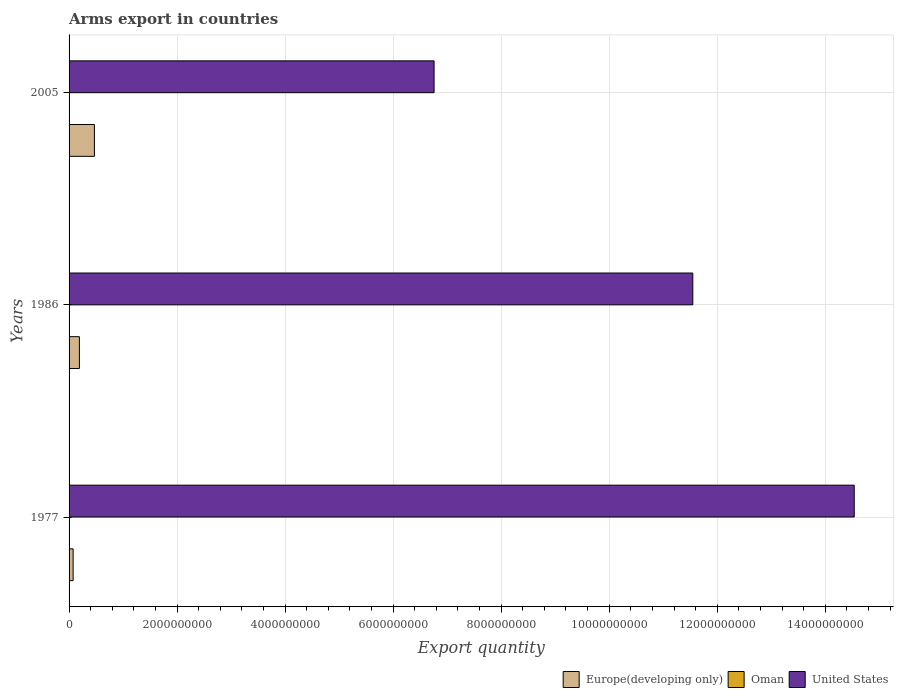How many groups of bars are there?
Keep it short and to the point. 3. Are the number of bars on each tick of the Y-axis equal?
Provide a short and direct response. Yes. How many bars are there on the 2nd tick from the top?
Make the answer very short. 3. How many bars are there on the 1st tick from the bottom?
Your response must be concise. 3. What is the label of the 3rd group of bars from the top?
Provide a short and direct response. 1977. What is the total arms export in Oman in 2005?
Provide a succinct answer. 1.00e+06. Across all years, what is the maximum total arms export in Europe(developing only)?
Give a very brief answer. 4.69e+08. Across all years, what is the minimum total arms export in Oman?
Offer a very short reply. 1.00e+06. In which year was the total arms export in United States maximum?
Your answer should be very brief. 1977. In which year was the total arms export in Europe(developing only) minimum?
Your answer should be compact. 1977. What is the total total arms export in United States in the graph?
Give a very brief answer. 3.28e+1. What is the difference between the total arms export in Oman in 1977 and the total arms export in Europe(developing only) in 1986?
Give a very brief answer. -1.86e+08. What is the average total arms export in Oman per year?
Make the answer very short. 3.67e+06. In the year 1986, what is the difference between the total arms export in Oman and total arms export in Europe(developing only)?
Offer a terse response. -1.86e+08. What is the ratio of the total arms export in Europe(developing only) in 1977 to that in 2005?
Your answer should be very brief. 0.16. What is the difference between the highest and the second highest total arms export in United States?
Provide a succinct answer. 2.99e+09. What is the difference between the highest and the lowest total arms export in United States?
Provide a succinct answer. 7.78e+09. In how many years, is the total arms export in Europe(developing only) greater than the average total arms export in Europe(developing only) taken over all years?
Your answer should be compact. 1. Is the sum of the total arms export in Oman in 1977 and 1986 greater than the maximum total arms export in Europe(developing only) across all years?
Make the answer very short. No. What does the 1st bar from the bottom in 1977 represents?
Ensure brevity in your answer.  Europe(developing only). Is it the case that in every year, the sum of the total arms export in Europe(developing only) and total arms export in United States is greater than the total arms export in Oman?
Ensure brevity in your answer.  Yes. Are all the bars in the graph horizontal?
Offer a very short reply. Yes. How many years are there in the graph?
Make the answer very short. 3. What is the difference between two consecutive major ticks on the X-axis?
Your response must be concise. 2.00e+09. Are the values on the major ticks of X-axis written in scientific E-notation?
Provide a short and direct response. No. How many legend labels are there?
Provide a short and direct response. 3. How are the legend labels stacked?
Make the answer very short. Horizontal. What is the title of the graph?
Give a very brief answer. Arms export in countries. Does "High income: OECD" appear as one of the legend labels in the graph?
Make the answer very short. No. What is the label or title of the X-axis?
Make the answer very short. Export quantity. What is the label or title of the Y-axis?
Ensure brevity in your answer.  Years. What is the Export quantity of Europe(developing only) in 1977?
Give a very brief answer. 7.50e+07. What is the Export quantity of Oman in 1977?
Make the answer very short. 5.00e+06. What is the Export quantity in United States in 1977?
Your answer should be compact. 1.45e+1. What is the Export quantity in Europe(developing only) in 1986?
Your answer should be very brief. 1.91e+08. What is the Export quantity in United States in 1986?
Your answer should be very brief. 1.15e+1. What is the Export quantity in Europe(developing only) in 2005?
Give a very brief answer. 4.69e+08. What is the Export quantity of United States in 2005?
Give a very brief answer. 6.76e+09. Across all years, what is the maximum Export quantity in Europe(developing only)?
Your answer should be very brief. 4.69e+08. Across all years, what is the maximum Export quantity in Oman?
Your answer should be compact. 5.00e+06. Across all years, what is the maximum Export quantity in United States?
Ensure brevity in your answer.  1.45e+1. Across all years, what is the minimum Export quantity of Europe(developing only)?
Make the answer very short. 7.50e+07. Across all years, what is the minimum Export quantity of Oman?
Your answer should be compact. 1.00e+06. Across all years, what is the minimum Export quantity in United States?
Provide a short and direct response. 6.76e+09. What is the total Export quantity in Europe(developing only) in the graph?
Offer a terse response. 7.35e+08. What is the total Export quantity in Oman in the graph?
Offer a very short reply. 1.10e+07. What is the total Export quantity of United States in the graph?
Make the answer very short. 3.28e+1. What is the difference between the Export quantity of Europe(developing only) in 1977 and that in 1986?
Give a very brief answer. -1.16e+08. What is the difference between the Export quantity of United States in 1977 and that in 1986?
Ensure brevity in your answer.  2.99e+09. What is the difference between the Export quantity of Europe(developing only) in 1977 and that in 2005?
Your answer should be compact. -3.94e+08. What is the difference between the Export quantity in Oman in 1977 and that in 2005?
Provide a short and direct response. 4.00e+06. What is the difference between the Export quantity in United States in 1977 and that in 2005?
Your answer should be compact. 7.78e+09. What is the difference between the Export quantity of Europe(developing only) in 1986 and that in 2005?
Your answer should be compact. -2.78e+08. What is the difference between the Export quantity of United States in 1986 and that in 2005?
Make the answer very short. 4.79e+09. What is the difference between the Export quantity of Europe(developing only) in 1977 and the Export quantity of Oman in 1986?
Offer a terse response. 7.00e+07. What is the difference between the Export quantity of Europe(developing only) in 1977 and the Export quantity of United States in 1986?
Your response must be concise. -1.15e+1. What is the difference between the Export quantity of Oman in 1977 and the Export quantity of United States in 1986?
Ensure brevity in your answer.  -1.15e+1. What is the difference between the Export quantity of Europe(developing only) in 1977 and the Export quantity of Oman in 2005?
Offer a terse response. 7.40e+07. What is the difference between the Export quantity of Europe(developing only) in 1977 and the Export quantity of United States in 2005?
Ensure brevity in your answer.  -6.68e+09. What is the difference between the Export quantity of Oman in 1977 and the Export quantity of United States in 2005?
Provide a short and direct response. -6.75e+09. What is the difference between the Export quantity of Europe(developing only) in 1986 and the Export quantity of Oman in 2005?
Ensure brevity in your answer.  1.90e+08. What is the difference between the Export quantity in Europe(developing only) in 1986 and the Export quantity in United States in 2005?
Give a very brief answer. -6.57e+09. What is the difference between the Export quantity in Oman in 1986 and the Export quantity in United States in 2005?
Offer a terse response. -6.75e+09. What is the average Export quantity in Europe(developing only) per year?
Your response must be concise. 2.45e+08. What is the average Export quantity in Oman per year?
Offer a terse response. 3.67e+06. What is the average Export quantity in United States per year?
Offer a very short reply. 1.09e+1. In the year 1977, what is the difference between the Export quantity of Europe(developing only) and Export quantity of Oman?
Provide a short and direct response. 7.00e+07. In the year 1977, what is the difference between the Export quantity of Europe(developing only) and Export quantity of United States?
Provide a short and direct response. -1.45e+1. In the year 1977, what is the difference between the Export quantity in Oman and Export quantity in United States?
Your answer should be compact. -1.45e+1. In the year 1986, what is the difference between the Export quantity in Europe(developing only) and Export quantity in Oman?
Your answer should be very brief. 1.86e+08. In the year 1986, what is the difference between the Export quantity of Europe(developing only) and Export quantity of United States?
Keep it short and to the point. -1.14e+1. In the year 1986, what is the difference between the Export quantity of Oman and Export quantity of United States?
Make the answer very short. -1.15e+1. In the year 2005, what is the difference between the Export quantity in Europe(developing only) and Export quantity in Oman?
Your answer should be compact. 4.68e+08. In the year 2005, what is the difference between the Export quantity of Europe(developing only) and Export quantity of United States?
Give a very brief answer. -6.29e+09. In the year 2005, what is the difference between the Export quantity in Oman and Export quantity in United States?
Ensure brevity in your answer.  -6.76e+09. What is the ratio of the Export quantity of Europe(developing only) in 1977 to that in 1986?
Offer a very short reply. 0.39. What is the ratio of the Export quantity in United States in 1977 to that in 1986?
Provide a short and direct response. 1.26. What is the ratio of the Export quantity in Europe(developing only) in 1977 to that in 2005?
Keep it short and to the point. 0.16. What is the ratio of the Export quantity of United States in 1977 to that in 2005?
Your answer should be very brief. 2.15. What is the ratio of the Export quantity of Europe(developing only) in 1986 to that in 2005?
Give a very brief answer. 0.41. What is the ratio of the Export quantity of United States in 1986 to that in 2005?
Offer a terse response. 1.71. What is the difference between the highest and the second highest Export quantity of Europe(developing only)?
Make the answer very short. 2.78e+08. What is the difference between the highest and the second highest Export quantity in United States?
Give a very brief answer. 2.99e+09. What is the difference between the highest and the lowest Export quantity in Europe(developing only)?
Give a very brief answer. 3.94e+08. What is the difference between the highest and the lowest Export quantity in Oman?
Offer a terse response. 4.00e+06. What is the difference between the highest and the lowest Export quantity of United States?
Your answer should be very brief. 7.78e+09. 